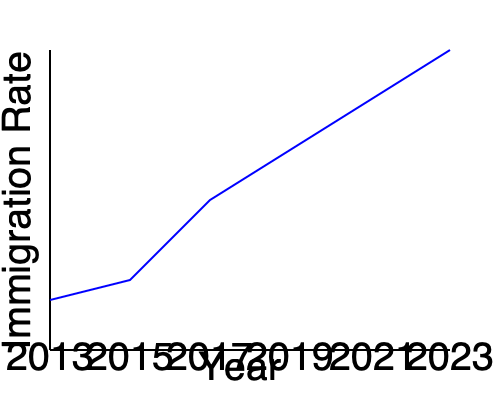Based on the line graph showing immigration rates over the past decade, what trend can be observed, and how might this information be relevant to a new immigrant seeking advice from a newsroom manager? To answer this question, let's analyze the graph step-by-step:

1. The x-axis represents years from 2013 to 2023, while the y-axis represents the immigration rate.

2. Observing the line from left to right, we can see that it consistently moves upward, indicating an increasing trend.

3. The slope of the line becomes steeper as we move from left to right, suggesting that the rate of increase is accelerating over time.

4. From 2013 to 2015, there's a slight increase in the immigration rate.

5. Between 2015 and 2017, there's a more noticeable increase.

6. From 2017 to 2023, the increase becomes even more pronounced, with the line becoming steeper.

This trend of increasing immigration rates is relevant to a new immigrant in several ways:

a) It suggests that more people are immigrating, potentially leading to increased competition for resources and services.

b) The accelerating trend might indicate that immigration policies are becoming more favorable or that there are growing opportunities for immigrants.

c) A newsroom manager could use this information to advise the new immigrant on the importance of staying informed about changing immigration policies and potential challenges due to increased immigration.

d) The trend might also suggest a need for the immigrant to act quickly in navigating the immigration process, as increased rates could lead to longer processing times or changes in policies.
Answer: Steadily increasing immigration rates, accelerating over time. 